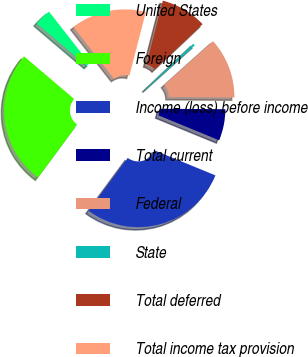Convert chart to OTSL. <chart><loc_0><loc_0><loc_500><loc_500><pie_chart><fcel>United States<fcel>Foreign<fcel>Income (loss) before income<fcel>Total current<fcel>Federal<fcel>State<fcel>Total deferred<fcel>Total income tax provision<nl><fcel>3.24%<fcel>26.09%<fcel>28.92%<fcel>6.08%<fcel>11.76%<fcel>0.41%<fcel>8.92%<fcel>14.59%<nl></chart> 